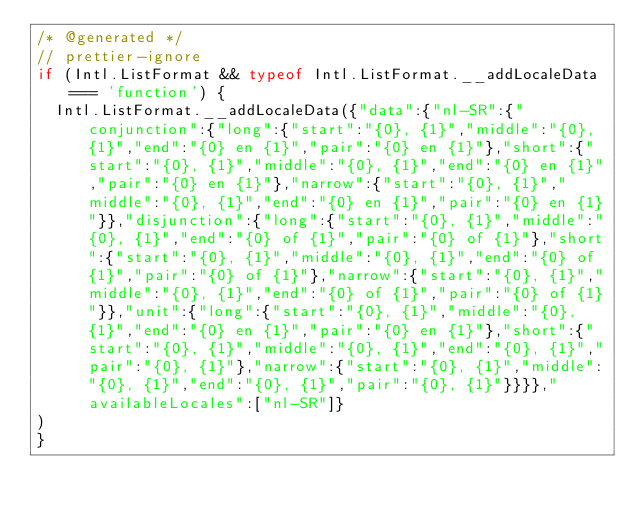Convert code to text. <code><loc_0><loc_0><loc_500><loc_500><_JavaScript_>/* @generated */	
// prettier-ignore
if (Intl.ListFormat && typeof Intl.ListFormat.__addLocaleData === 'function') {
  Intl.ListFormat.__addLocaleData({"data":{"nl-SR":{"conjunction":{"long":{"start":"{0}, {1}","middle":"{0}, {1}","end":"{0} en {1}","pair":"{0} en {1}"},"short":{"start":"{0}, {1}","middle":"{0}, {1}","end":"{0} en {1}","pair":"{0} en {1}"},"narrow":{"start":"{0}, {1}","middle":"{0}, {1}","end":"{0} en {1}","pair":"{0} en {1}"}},"disjunction":{"long":{"start":"{0}, {1}","middle":"{0}, {1}","end":"{0} of {1}","pair":"{0} of {1}"},"short":{"start":"{0}, {1}","middle":"{0}, {1}","end":"{0} of {1}","pair":"{0} of {1}"},"narrow":{"start":"{0}, {1}","middle":"{0}, {1}","end":"{0} of {1}","pair":"{0} of {1}"}},"unit":{"long":{"start":"{0}, {1}","middle":"{0}, {1}","end":"{0} en {1}","pair":"{0} en {1}"},"short":{"start":"{0}, {1}","middle":"{0}, {1}","end":"{0}, {1}","pair":"{0}, {1}"},"narrow":{"start":"{0}, {1}","middle":"{0}, {1}","end":"{0}, {1}","pair":"{0}, {1}"}}}},"availableLocales":["nl-SR"]}
)
}</code> 